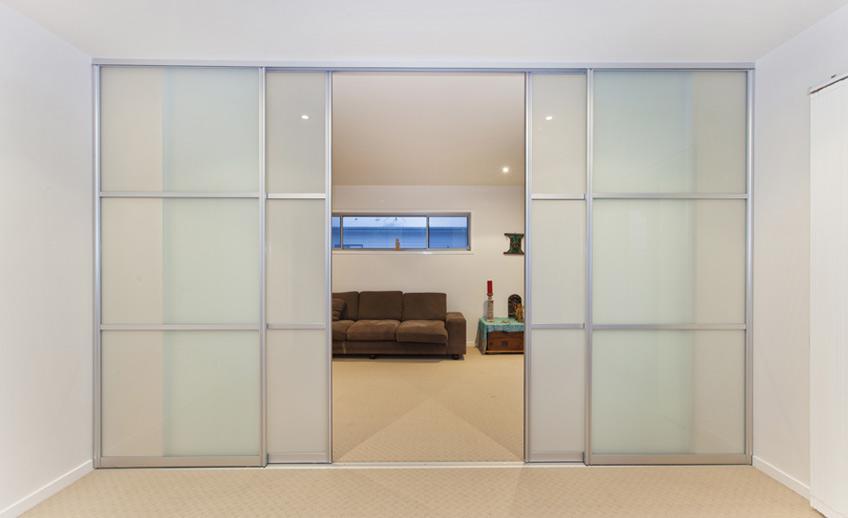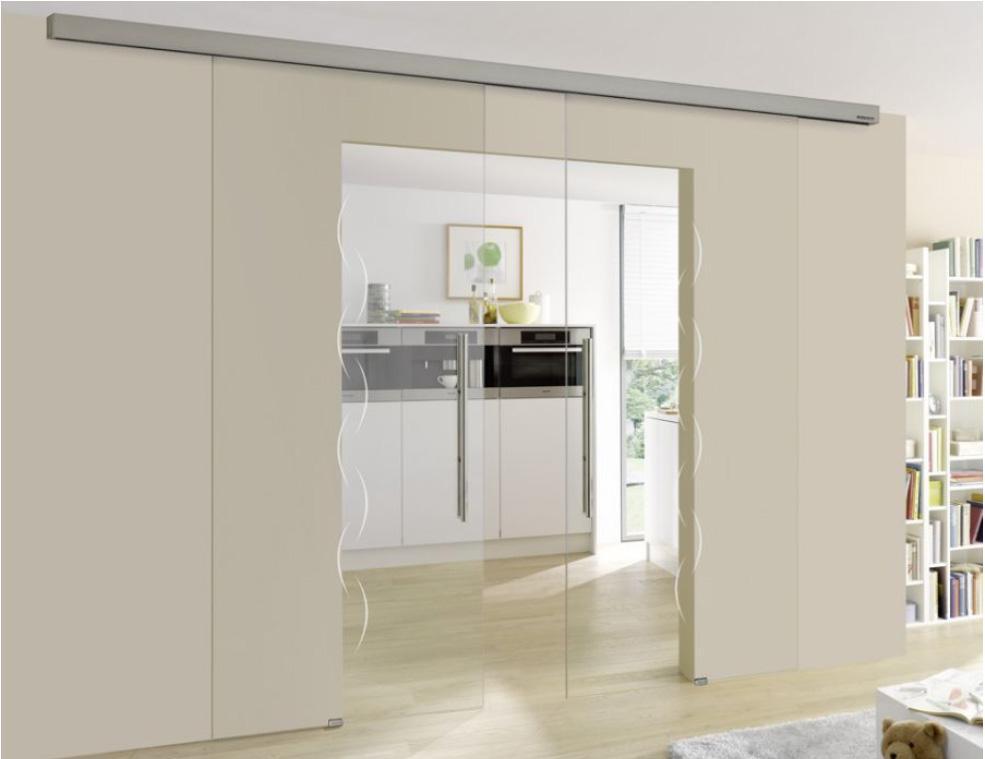The first image is the image on the left, the second image is the image on the right. Evaluate the accuracy of this statement regarding the images: "One set of sliding doors is white.". Is it true? Answer yes or no. No. 